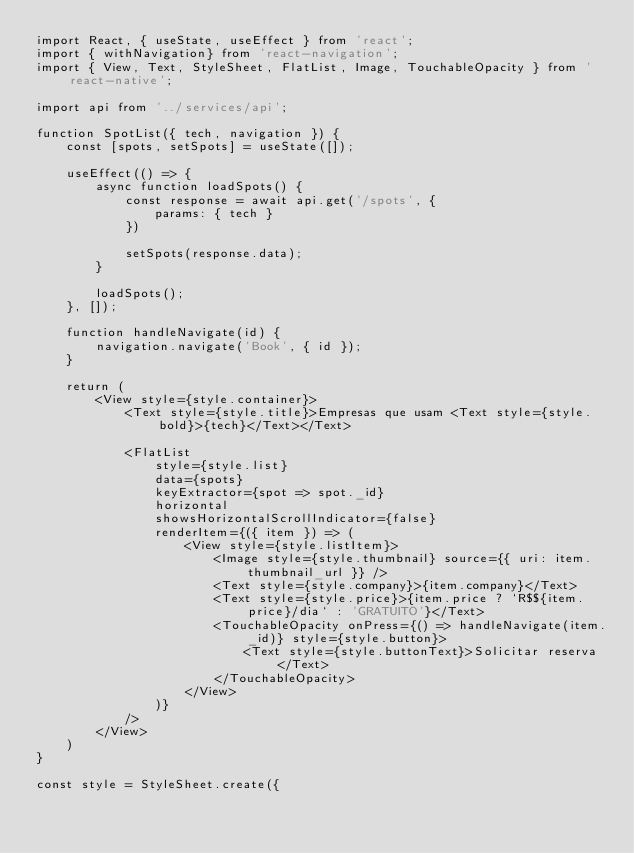<code> <loc_0><loc_0><loc_500><loc_500><_JavaScript_>import React, { useState, useEffect } from 'react';
import { withNavigation} from 'react-navigation';
import { View, Text, StyleSheet, FlatList, Image, TouchableOpacity } from 'react-native';

import api from '../services/api';

function SpotList({ tech, navigation }) {
    const [spots, setSpots] = useState([]);

    useEffect(() => {
        async function loadSpots() {
            const response = await api.get('/spots', {
                params: { tech }
            })

            setSpots(response.data);
        }

        loadSpots();
    }, []);

    function handleNavigate(id) {
        navigation.navigate('Book', { id });
    }

    return (
        <View style={style.container}>
            <Text style={style.title}>Empresas que usam <Text style={style.bold}>{tech}</Text></Text>

            <FlatList 
                style={style.list}
                data={spots}
                keyExtractor={spot => spot._id}
                horizontal
                showsHorizontalScrollIndicator={false}
                renderItem={({ item }) => (
                    <View style={style.listItem}>
                        <Image style={style.thumbnail} source={{ uri: item.thumbnail_url }} />
                        <Text style={style.company}>{item.company}</Text>
                        <Text style={style.price}>{item.price ? `R$${item.price}/dia` : 'GRATUITO'}</Text>
                        <TouchableOpacity onPress={() => handleNavigate(item._id)} style={style.button}>
                            <Text style={style.buttonText}>Solicitar reserva</Text>
                        </TouchableOpacity>
                    </View>
                )}
            />
        </View>
    )
}

const style = StyleSheet.create({</code> 